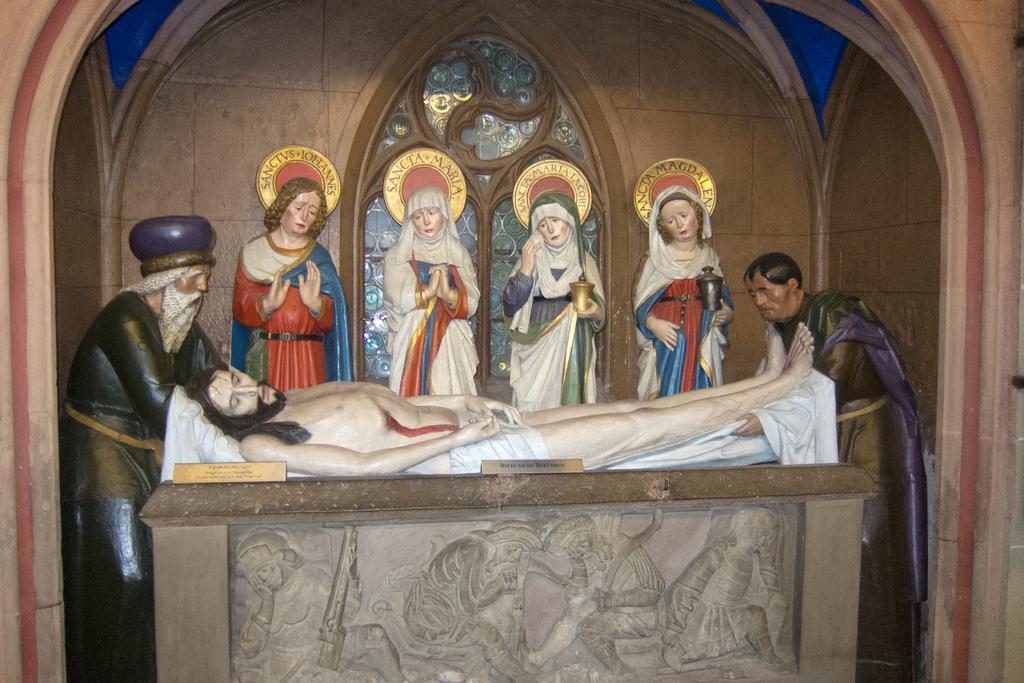Describe this image in one or two sentences. In this image we can see three men and four women statues. At the bottom of the image, we can see sculptures. In the background of the image, we can see a wall. 